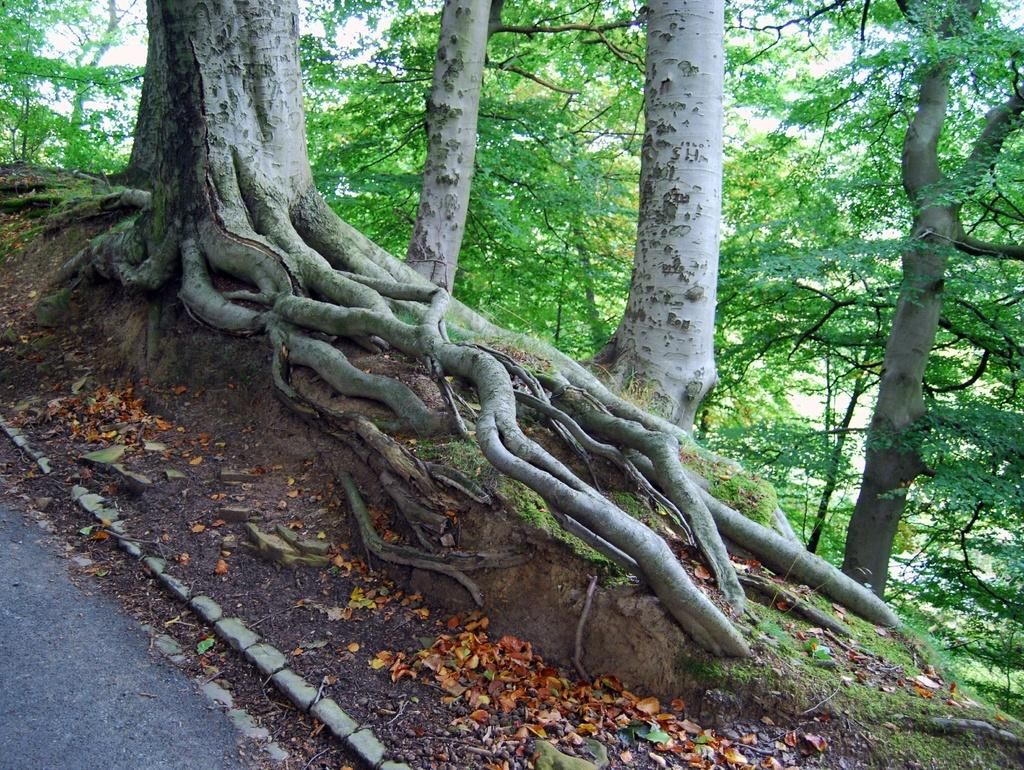What can be seen on the side of the road in the image? There are many trees on the side of the road in the image. Can you describe the landscape in the image? The landscape features a road with trees on either side. What type of design is featured on the badge of the cloud in the image? There is no badge or cloud present in the image; it only features trees on the side of the road. 